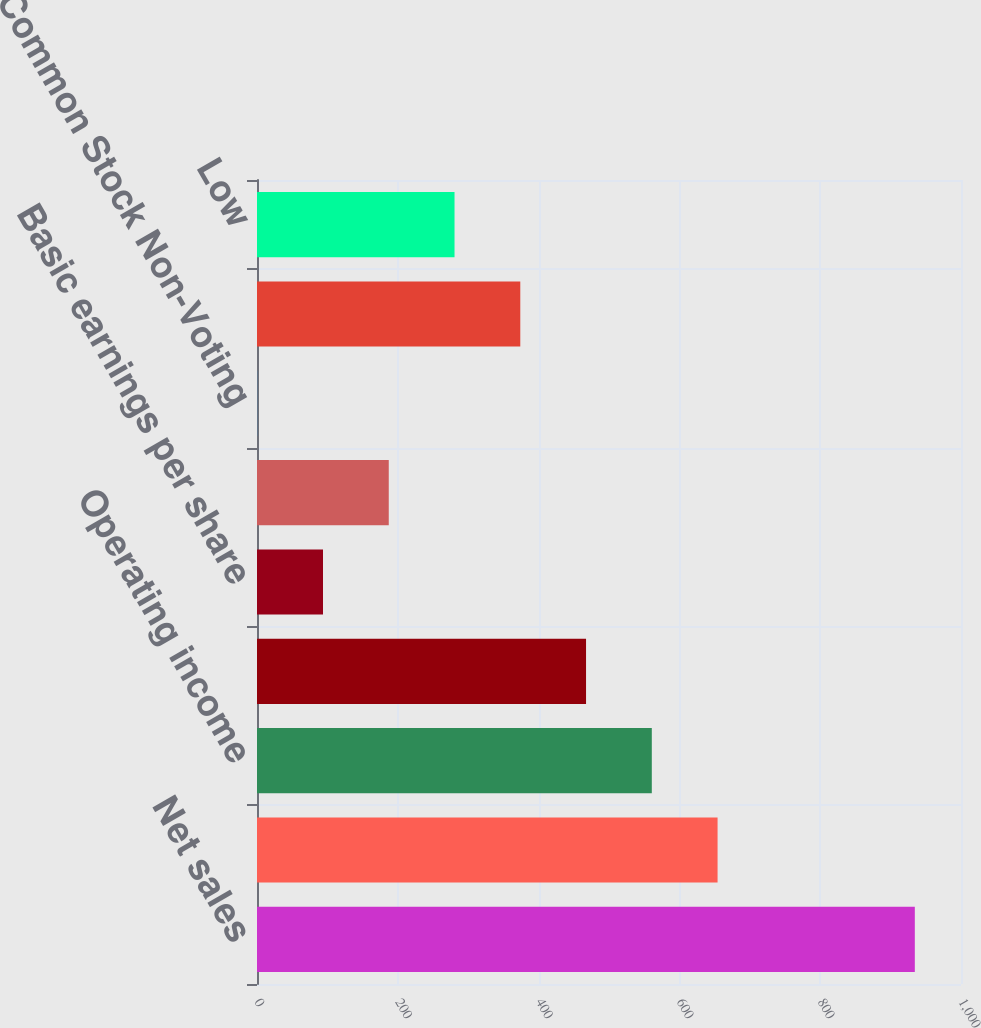<chart> <loc_0><loc_0><loc_500><loc_500><bar_chart><fcel>Net sales<fcel>Gross profit<fcel>Operating income<fcel>Net income<fcel>Basic earnings per share<fcel>Diluted earnings per share<fcel>Common Stock Non-Voting<fcel>High<fcel>Low<nl><fcel>934.4<fcel>654.21<fcel>560.8<fcel>467.39<fcel>93.75<fcel>187.16<fcel>0.34<fcel>373.98<fcel>280.57<nl></chart> 